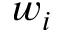Convert formula to latex. <formula><loc_0><loc_0><loc_500><loc_500>w _ { i }</formula> 